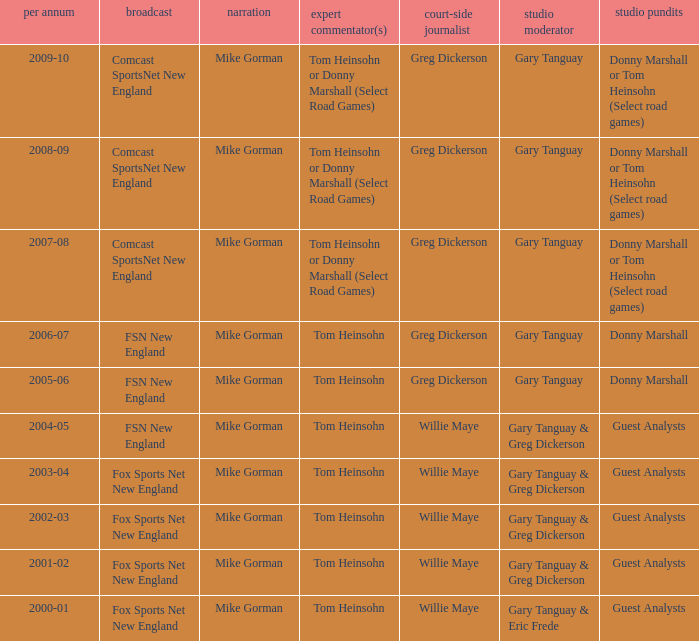WHich Studio host has a Year of 2003-04? Gary Tanguay & Greg Dickerson. 